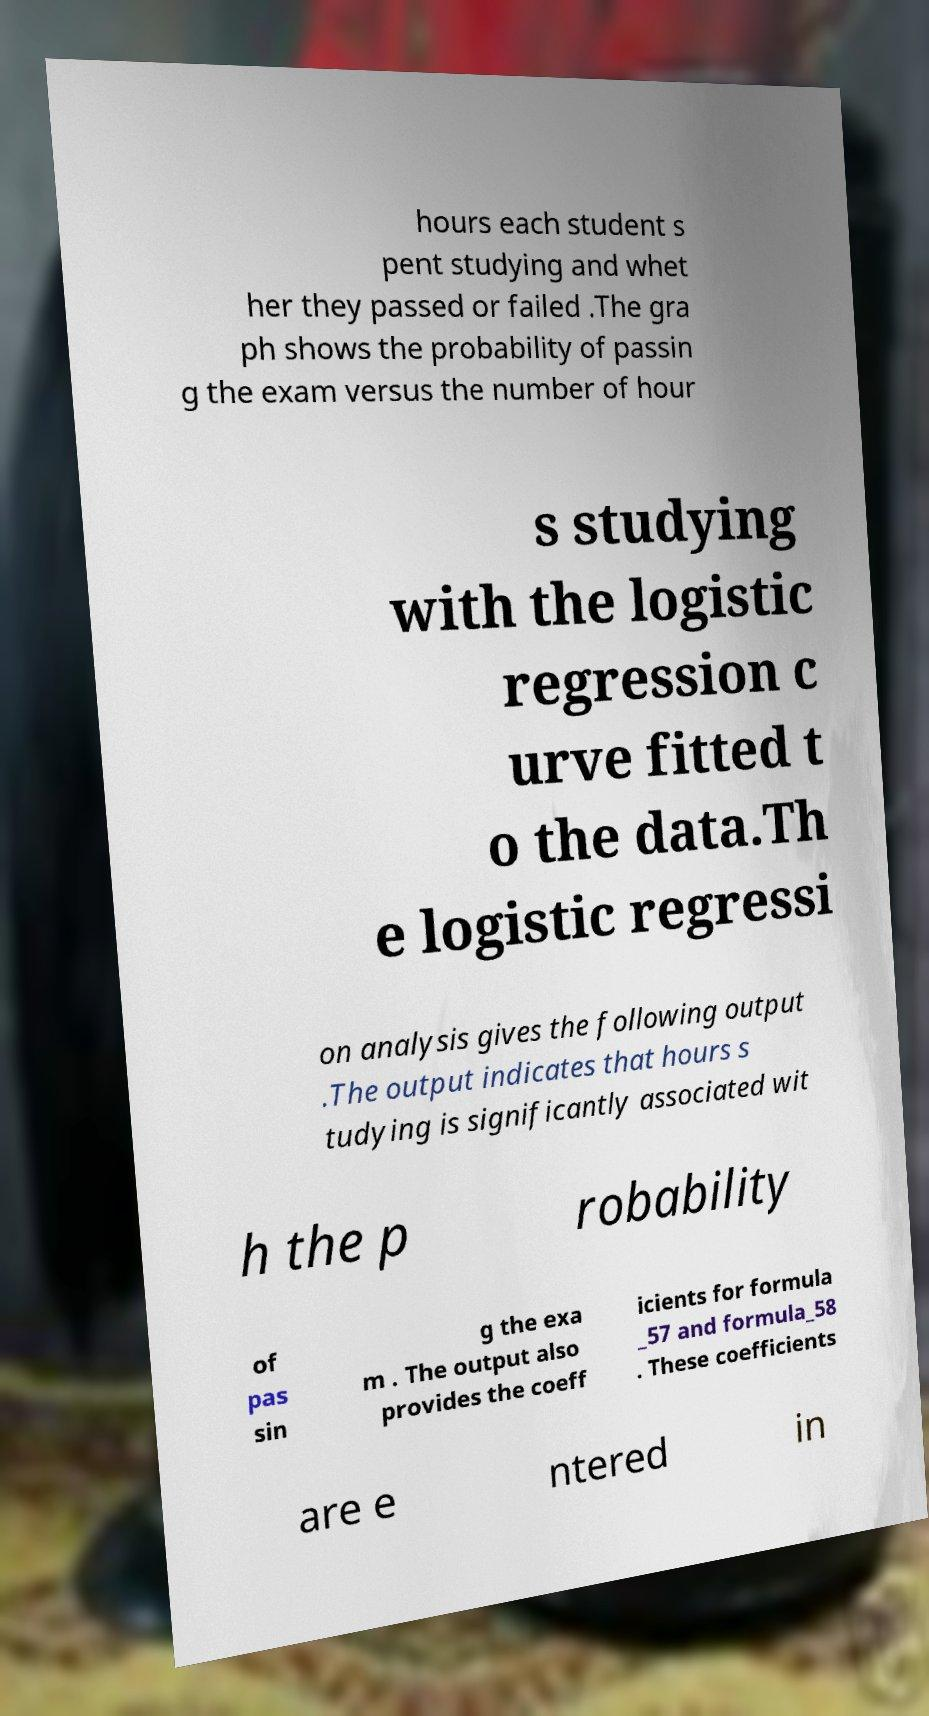Could you assist in decoding the text presented in this image and type it out clearly? hours each student s pent studying and whet her they passed or failed .The gra ph shows the probability of passin g the exam versus the number of hour s studying with the logistic regression c urve fitted t o the data.Th e logistic regressi on analysis gives the following output .The output indicates that hours s tudying is significantly associated wit h the p robability of pas sin g the exa m . The output also provides the coeff icients for formula _57 and formula_58 . These coefficients are e ntered in 